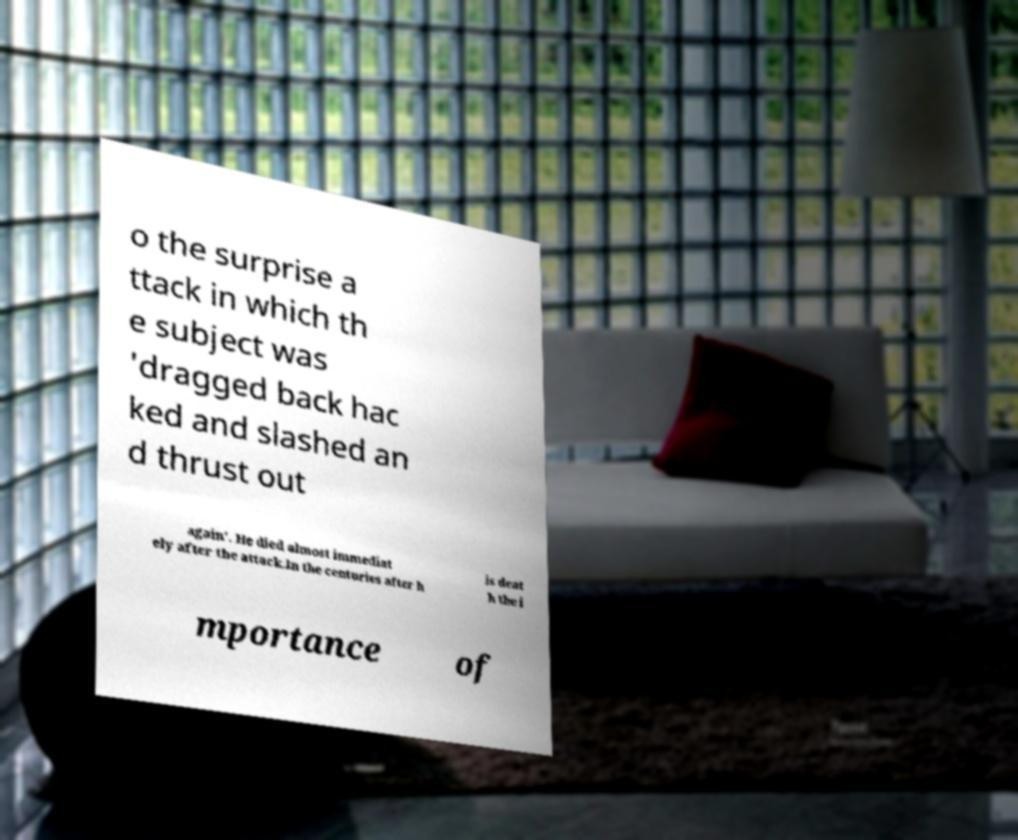Could you assist in decoding the text presented in this image and type it out clearly? o the surprise a ttack in which th e subject was 'dragged back hac ked and slashed an d thrust out again'. He died almost immediat ely after the attack.In the centuries after h is deat h the i mportance of 